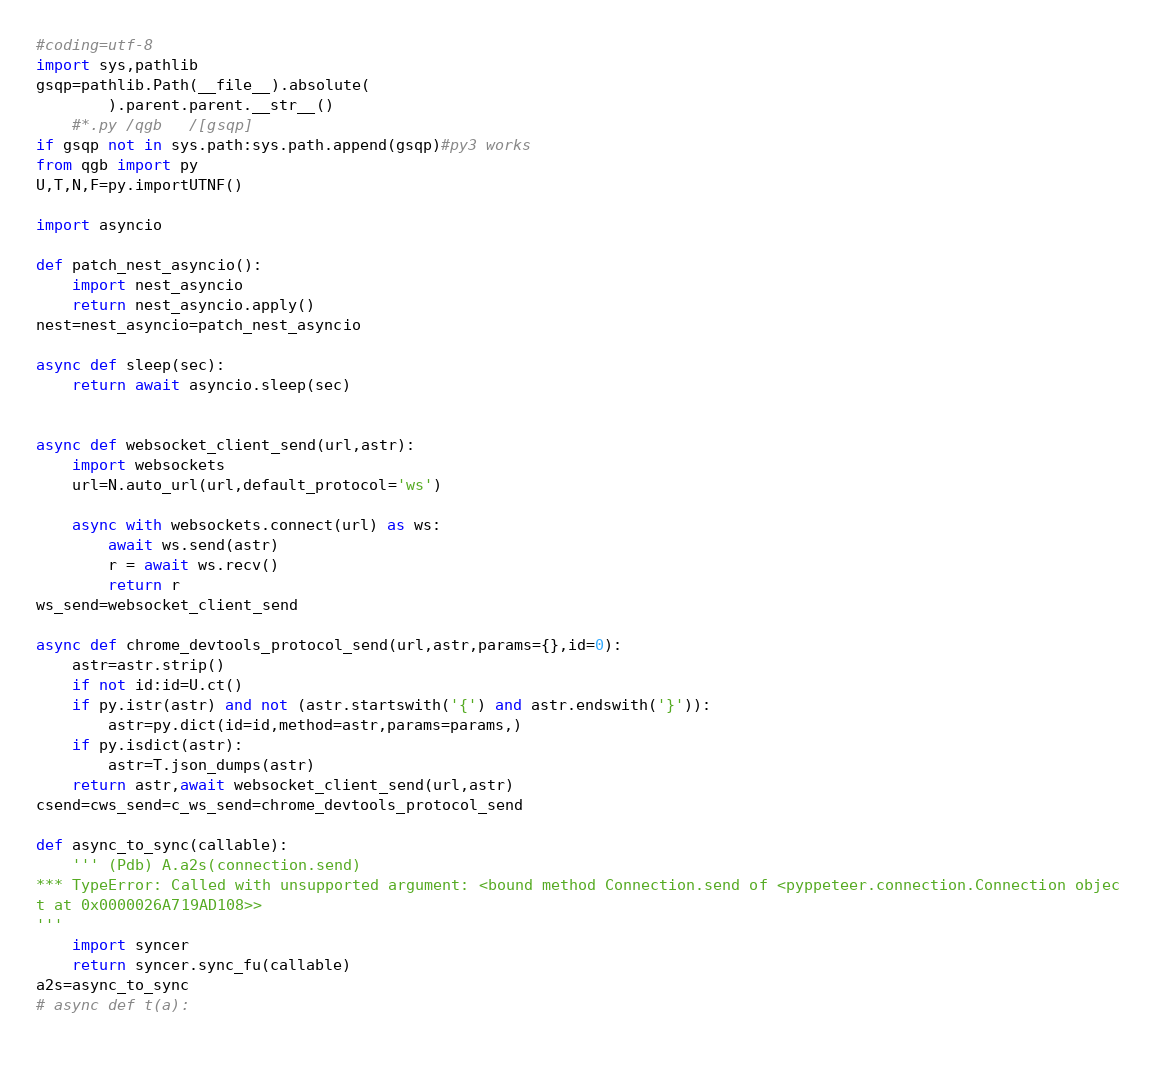<code> <loc_0><loc_0><loc_500><loc_500><_Python_>#coding=utf-8
import sys,pathlib
gsqp=pathlib.Path(__file__).absolute(
		).parent.parent.__str__()
	#*.py /qgb   /[gsqp]  
if gsqp not in sys.path:sys.path.append(gsqp)#py3 works
from qgb import py
U,T,N,F=py.importUTNF()

import asyncio

def patch_nest_asyncio():
	import nest_asyncio
	return nest_asyncio.apply()
nest=nest_asyncio=patch_nest_asyncio
	
async def sleep(sec):
	return await asyncio.sleep(sec)
	
	
async def websocket_client_send(url,astr):
	import websockets
	url=N.auto_url(url,default_protocol='ws')
	
	async with websockets.connect(url) as ws:
		await ws.send(astr)
		r = await ws.recv()
		return r
ws_send=websocket_client_send		

async def chrome_devtools_protocol_send(url,astr,params={},id=0):
	astr=astr.strip()
	if not id:id=U.ct()
	if py.istr(astr) and not (astr.startswith('{') and astr.endswith('}')):
		astr=py.dict(id=id,method=astr,params=params,)
	if py.isdict(astr):
		astr=T.json_dumps(astr)
	return astr,await websocket_client_send(url,astr)
csend=cws_send=c_ws_send=chrome_devtools_protocol_send

def async_to_sync(callable):
	''' (Pdb) A.a2s(connection.send)
*** TypeError: Called with unsupported argument: <bound method Connection.send of <pyppeteer.connection.Connection objec
t at 0x0000026A719AD108>>
'''
	import syncer
	return syncer.sync_fu(callable)
a2s=async_to_sync
# async def t(a):
	</code> 